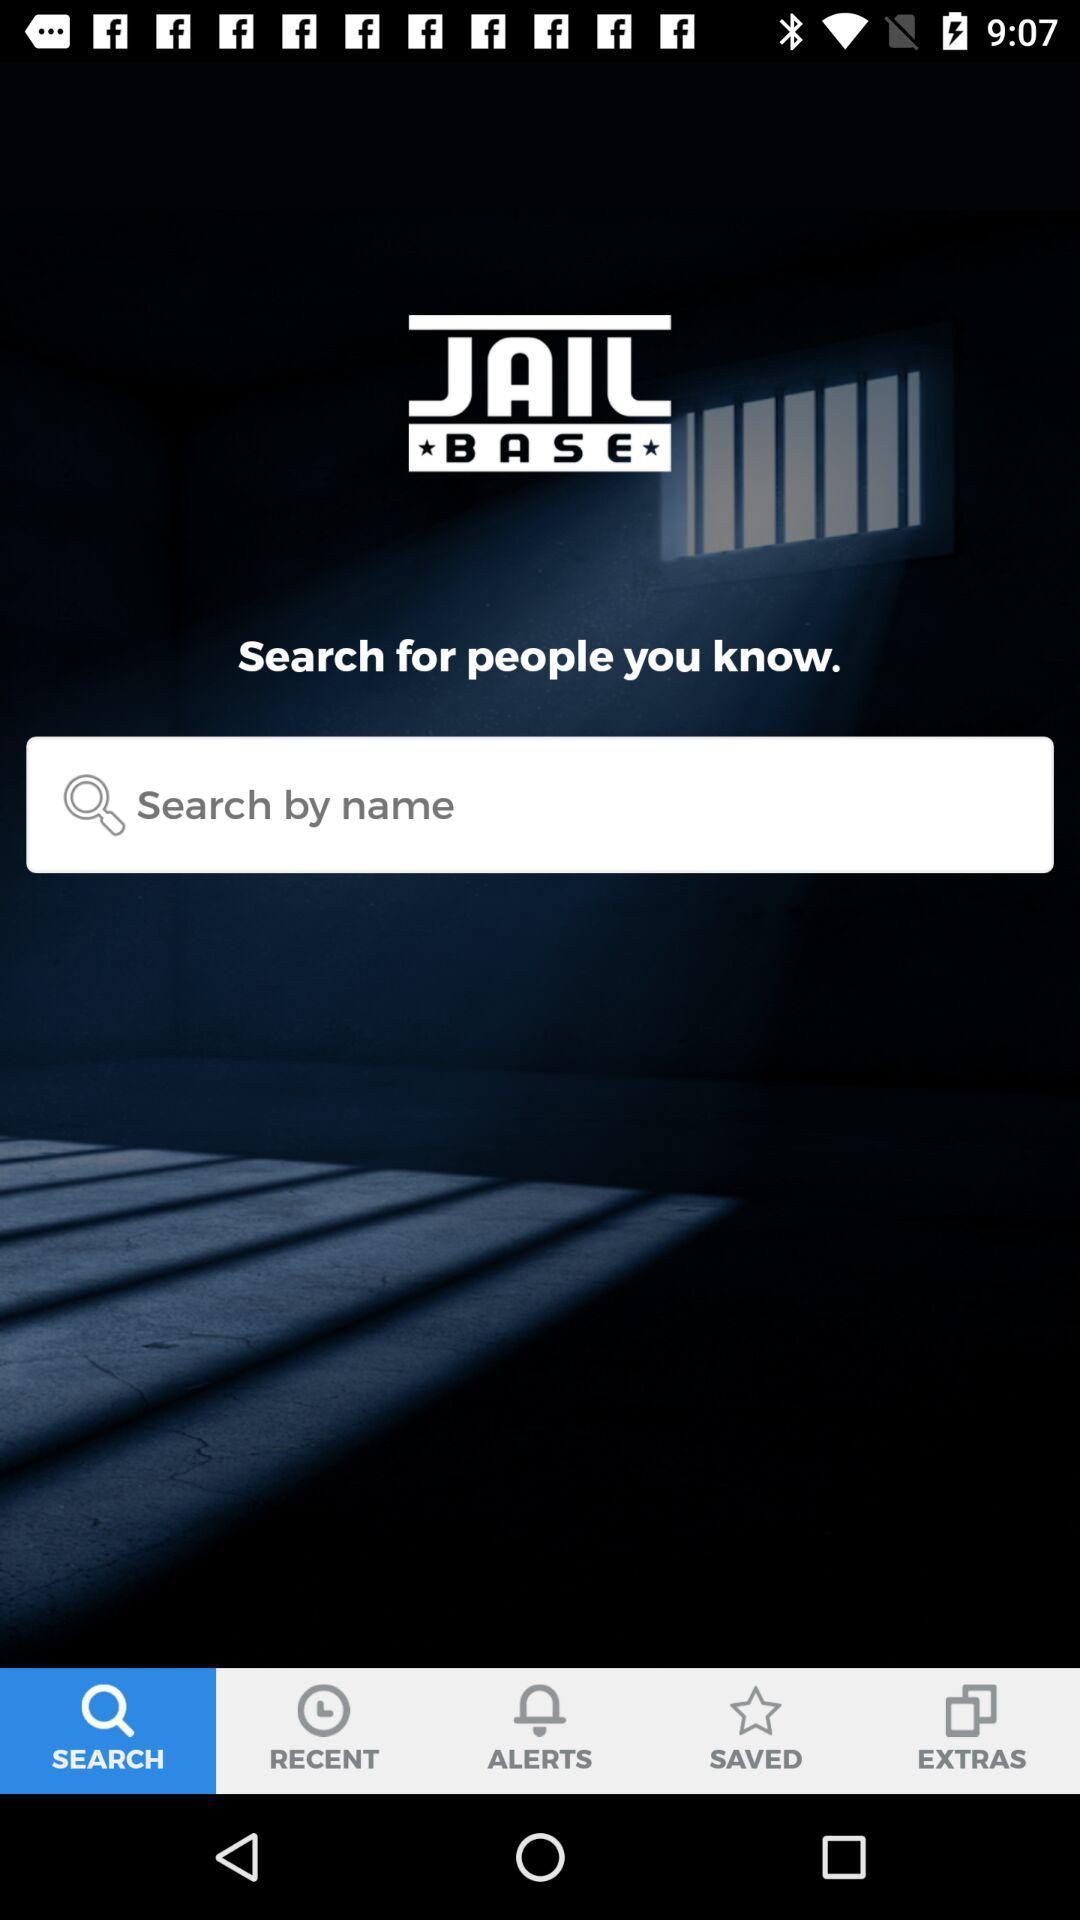Which tab is selected? The selected tab is "SEARCH". 